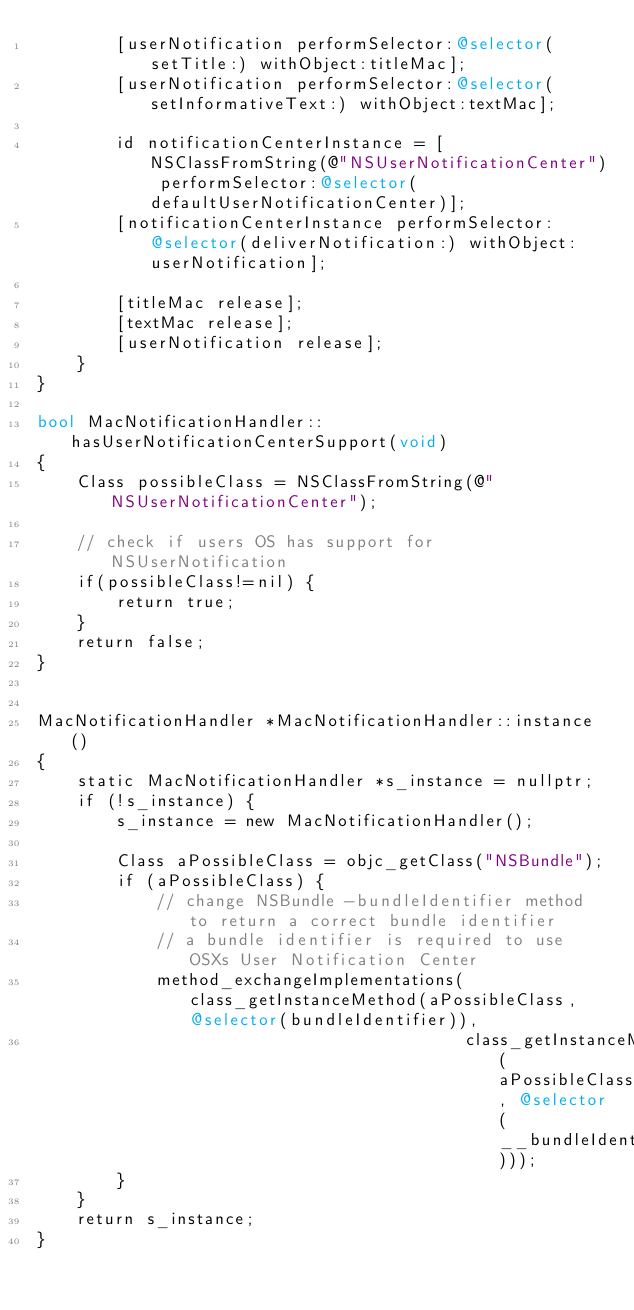<code> <loc_0><loc_0><loc_500><loc_500><_ObjectiveC_>        [userNotification performSelector:@selector(setTitle:) withObject:titleMac];
        [userNotification performSelector:@selector(setInformativeText:) withObject:textMac];

        id notificationCenterInstance = [NSClassFromString(@"NSUserNotificationCenter") performSelector:@selector(defaultUserNotificationCenter)];
        [notificationCenterInstance performSelector:@selector(deliverNotification:) withObject:userNotification];

        [titleMac release];
        [textMac release];
        [userNotification release];
    }
}

bool MacNotificationHandler::hasUserNotificationCenterSupport(void)
{
    Class possibleClass = NSClassFromString(@"NSUserNotificationCenter");

    // check if users OS has support for NSUserNotification
    if(possibleClass!=nil) {
        return true;
    }
    return false;
}


MacNotificationHandler *MacNotificationHandler::instance()
{
    static MacNotificationHandler *s_instance = nullptr;
    if (!s_instance) {
        s_instance = new MacNotificationHandler();
        
        Class aPossibleClass = objc_getClass("NSBundle");
        if (aPossibleClass) {
            // change NSBundle -bundleIdentifier method to return a correct bundle identifier
            // a bundle identifier is required to use OSXs User Notification Center
            method_exchangeImplementations(class_getInstanceMethod(aPossibleClass, @selector(bundleIdentifier)),
                                           class_getInstanceMethod(aPossibleClass, @selector(__bundleIdentifier)));
        }
    }
    return s_instance;
}
</code> 